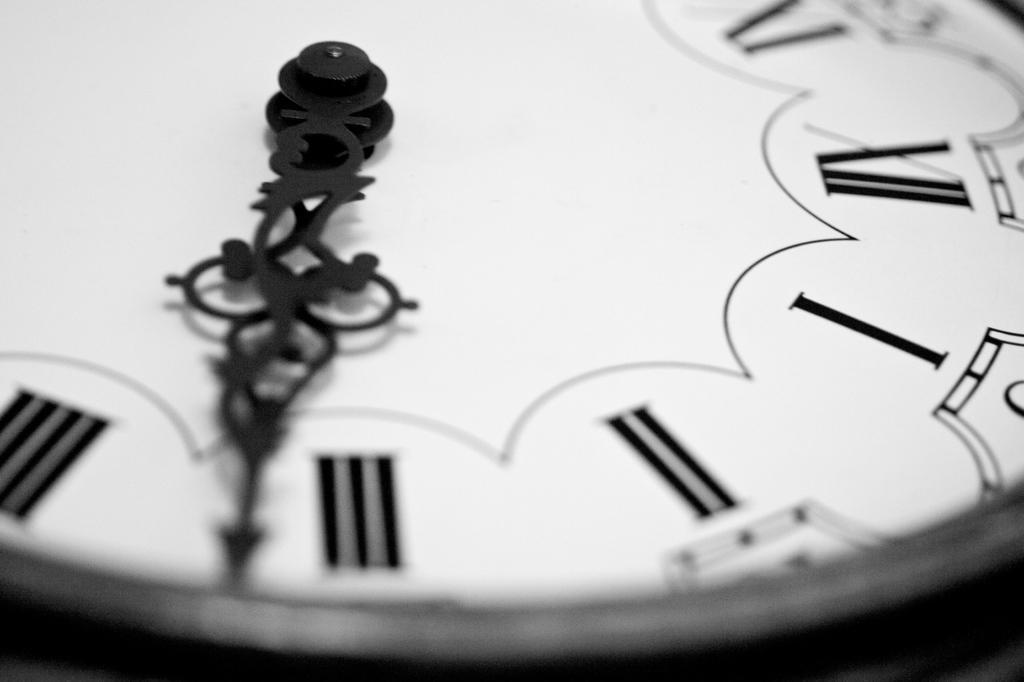Describe this image in one or two sentences. This is a black and white image and here we can see the clock. 